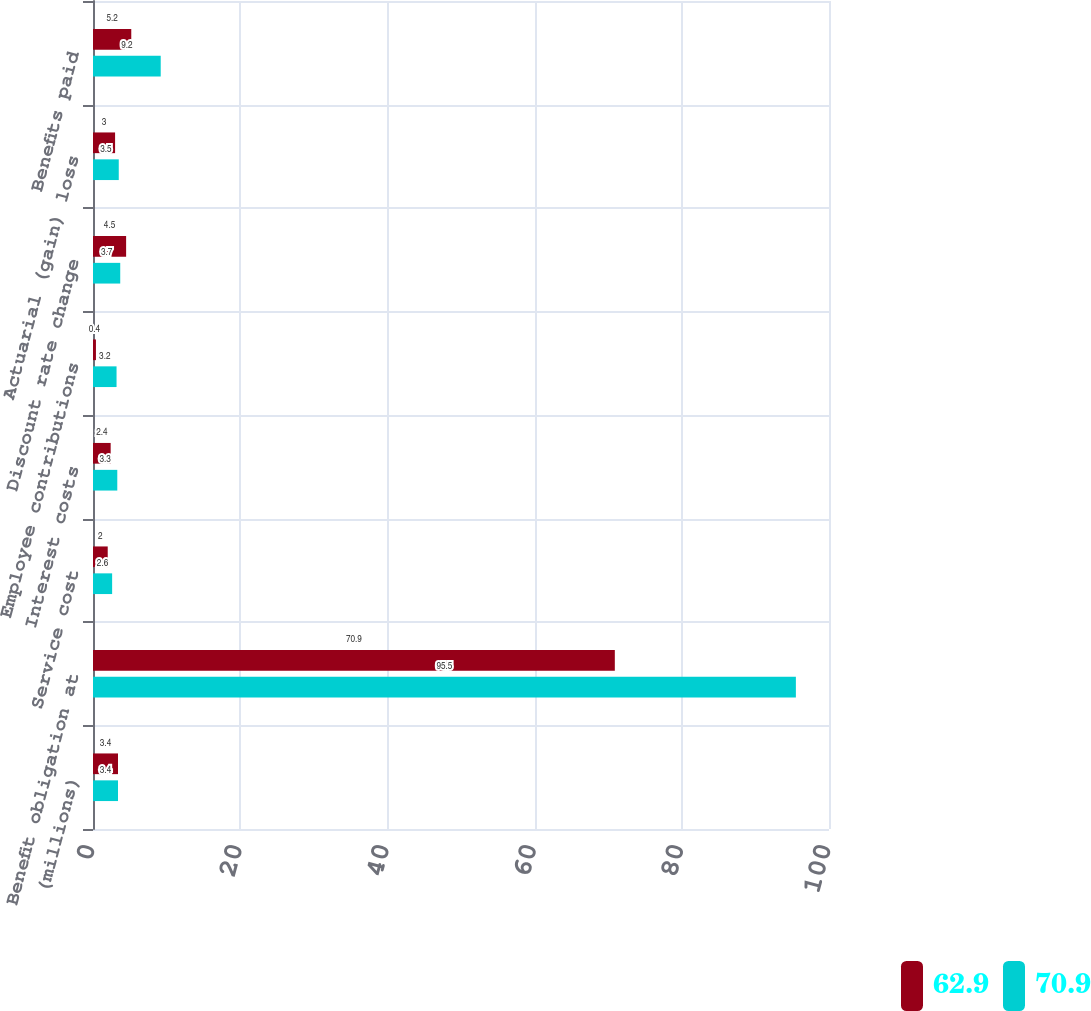Convert chart to OTSL. <chart><loc_0><loc_0><loc_500><loc_500><stacked_bar_chart><ecel><fcel>(millions)<fcel>Benefit obligation at<fcel>Service cost<fcel>Interest costs<fcel>Employee contributions<fcel>Discount rate change<fcel>Actuarial (gain) loss<fcel>Benefits paid<nl><fcel>62.9<fcel>3.4<fcel>70.9<fcel>2<fcel>2.4<fcel>0.4<fcel>4.5<fcel>3<fcel>5.2<nl><fcel>70.9<fcel>3.4<fcel>95.5<fcel>2.6<fcel>3.3<fcel>3.2<fcel>3.7<fcel>3.5<fcel>9.2<nl></chart> 